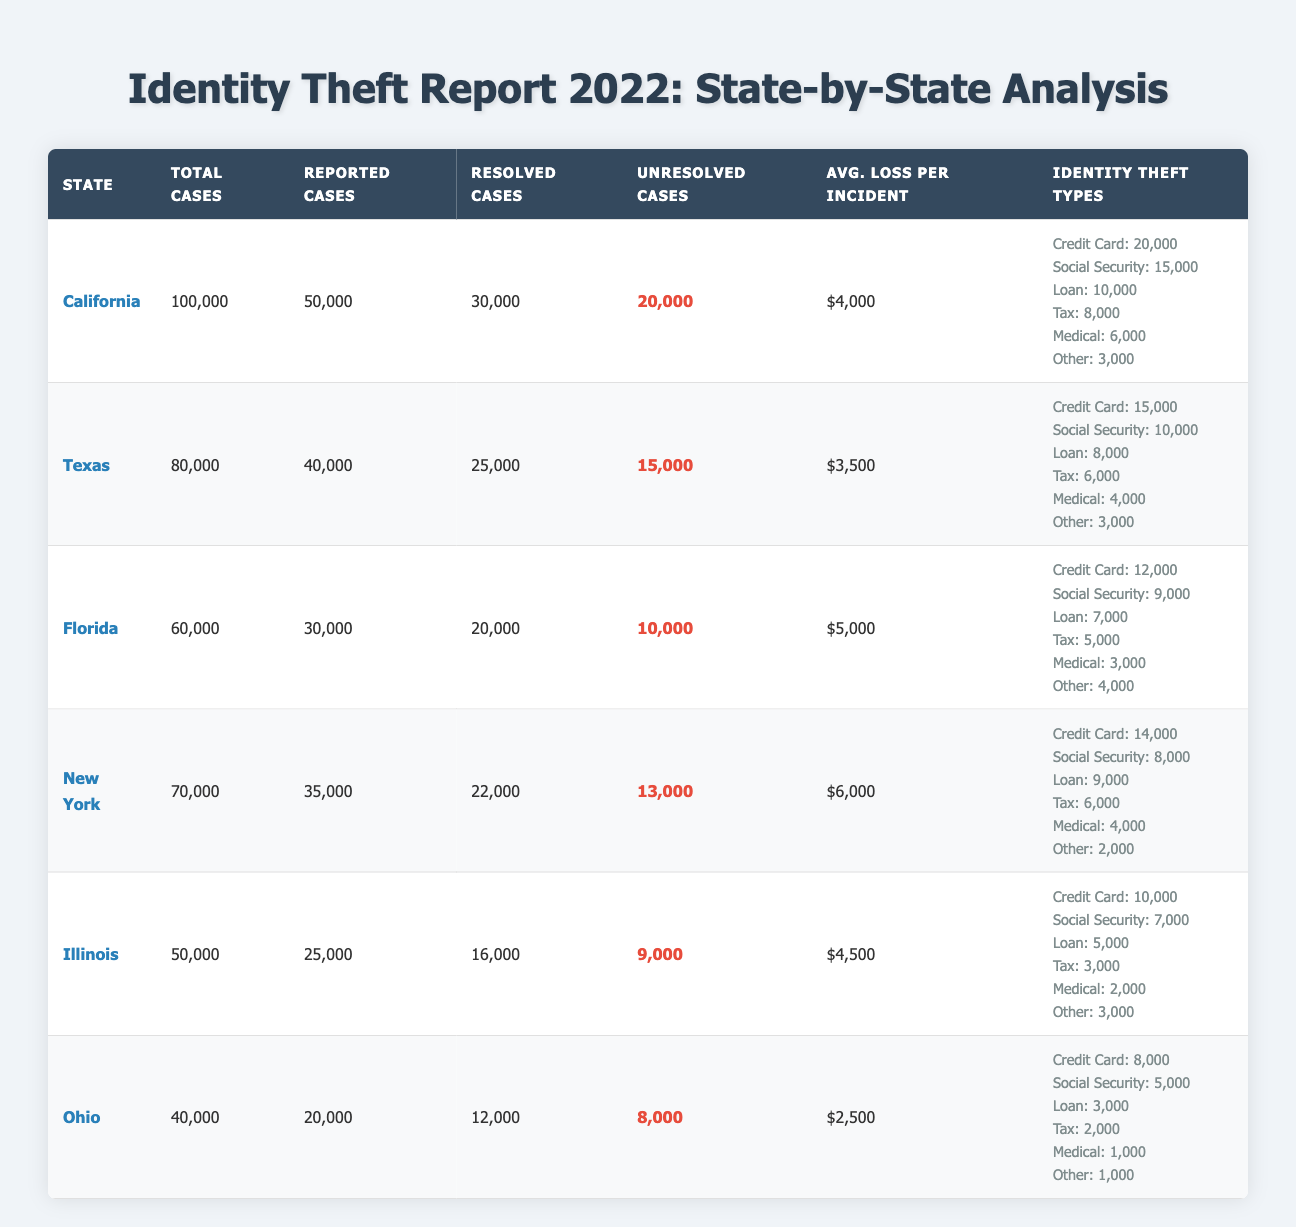What state reported the highest number of identity theft cases in 2022? Referring to the table, California has the highest number of reported identity theft cases, with 50,000 cases.
Answer: California What is the total number of unresolved identity theft cases in New York? The table shows that New York has 13,000 unresolved cases reported.
Answer: 13,000 Which state had the highest average loss per incident due to identity theft? New York shows the highest average loss per incident at $6,000, compared to other states listed in the table.
Answer: $6,000 How many more unresolved cases were there in California compared to Florida? California has 20,000 unresolved cases and Florida has 10,000. The difference is 20,000 - 10,000 = 10,000 cases.
Answer: 10,000 What percentage of reported identity theft cases in Texas were resolved? Texas had 40,000 reported cases and 25,000 were resolved. The percentage is (25,000 / 40,000) * 100 = 62.5%.
Answer: 62.5% Which identity theft type had the least number of cases reported in Ohio? Ohio reported only 1,000 cases for both Medical Fraud and Other types, which are the least.
Answer: Medical Fraud and Other How many total identity theft cases were reported across all states combined? Calculating the total: 50,000 (California) + 40,000 (Texas) + 30,000 (Florida) + 35,000 (New York) + 25,000 (Illinois) + 20,000 (Ohio) = 200,000 cases reported in total across all states.
Answer: 200,000 Was the average loss per incident in Illinois greater than in Ohio? Illinois reported an average loss of $4,500 while Ohio reported $2,500; thus, $4,500 > $2,500, making this statement true.
Answer: Yes What is the total number of resolved cases in all 2022 reports? Adding all resolved cases: 30,000 (California) + 25,000 (Texas) + 20,000 (Florida) + 22,000 (New York) + 16,000 (Illinois) + 12,000 (Ohio) = 135,000 resolved cases throughout all states.
Answer: 135,000 Which state had the least total number of cases reported in 2022? According to the table, Ohio had the least total number of cases, with 40,000.
Answer: Ohio In terms of credit card fraud, which state experienced the highest number of incidents? California reported 20,000 incidents of credit card fraud, which is the highest among the states listed.
Answer: California 